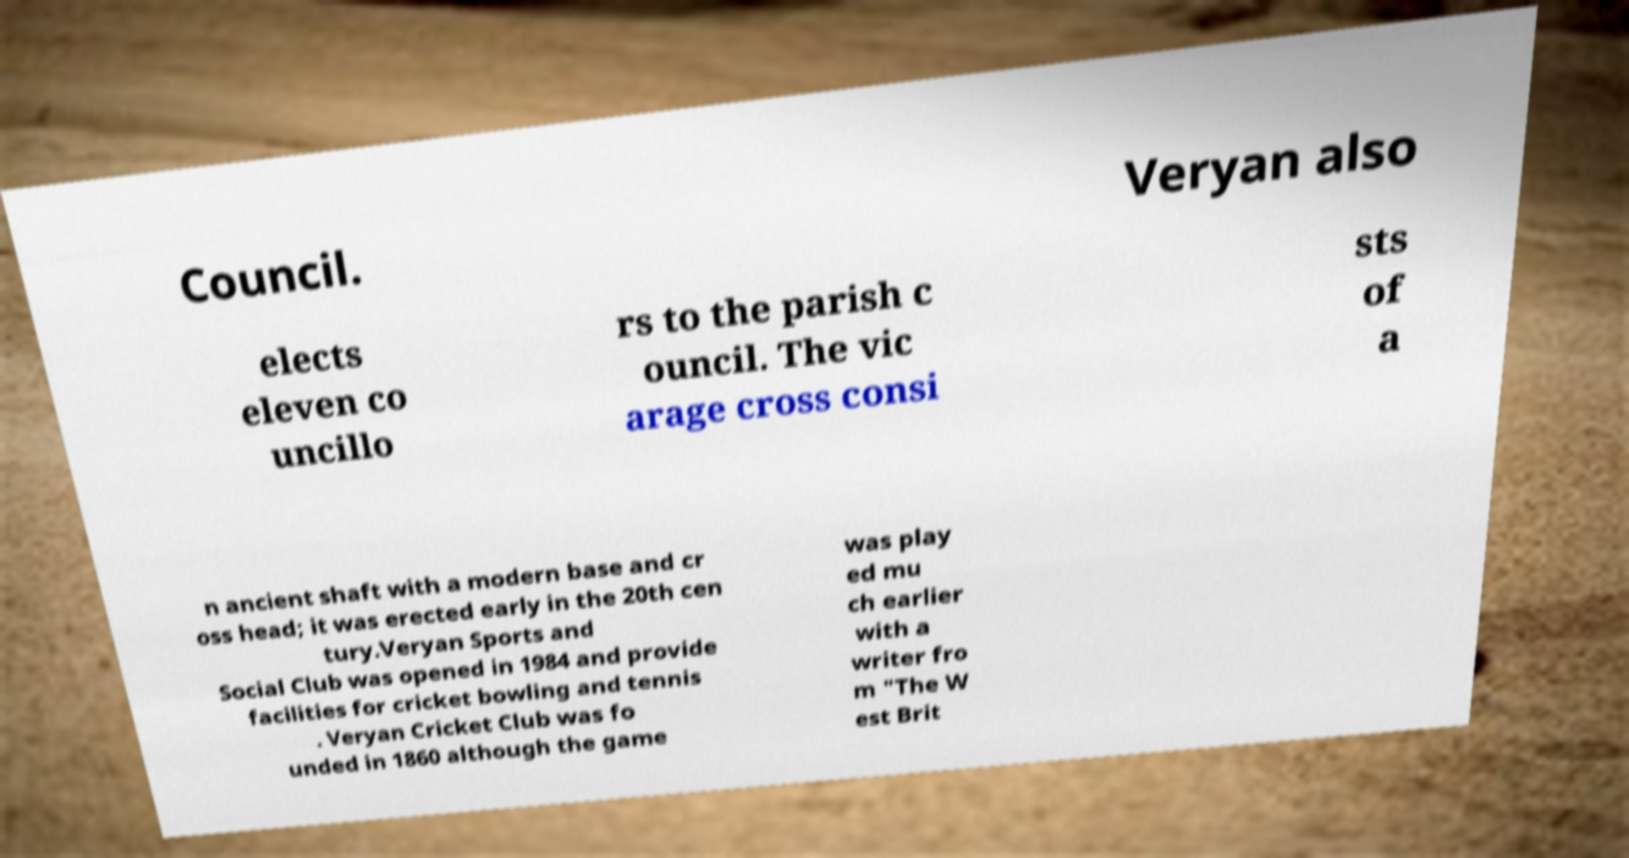I need the written content from this picture converted into text. Can you do that? Council. Veryan also elects eleven co uncillo rs to the parish c ouncil. The vic arage cross consi sts of a n ancient shaft with a modern base and cr oss head; it was erected early in the 20th cen tury.Veryan Sports and Social Club was opened in 1984 and provide facilities for cricket bowling and tennis . Veryan Cricket Club was fo unded in 1860 although the game was play ed mu ch earlier with a writer fro m "The W est Brit 